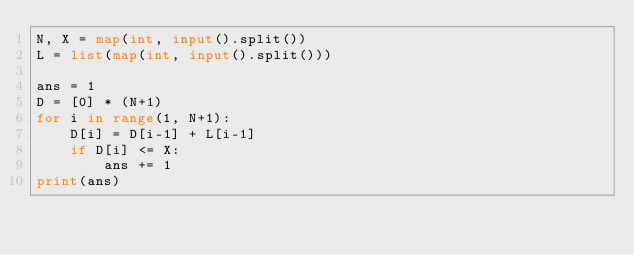<code> <loc_0><loc_0><loc_500><loc_500><_Python_>N, X = map(int, input().split())
L = list(map(int, input().split()))

ans = 1
D = [0] * (N+1)
for i in range(1, N+1):
    D[i] = D[i-1] + L[i-1]
    if D[i] <= X:
        ans += 1
print(ans)</code> 